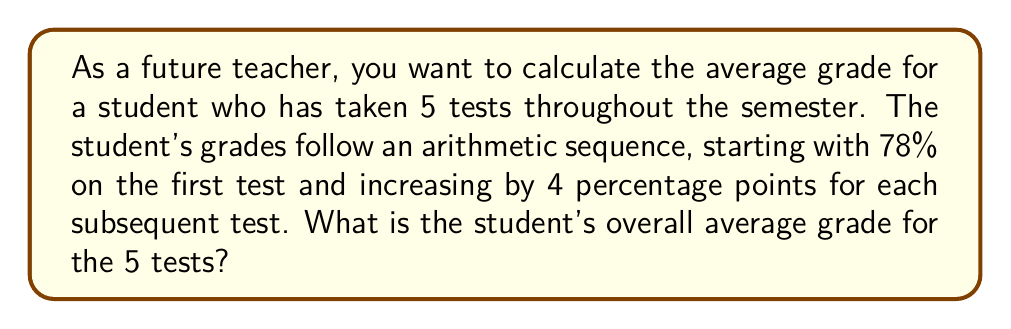Could you help me with this problem? Let's approach this step-by-step using the concept of arithmetic series:

1) First, let's identify the components of our arithmetic sequence:
   $a_1 = 78$ (first term)
   $d = 4$ (common difference)
   $n = 5$ (number of terms)

2) The arithmetic sequence of grades would be:
   78, 82, 86, 90, 94

3) To find the average, we need to find the sum of all grades and divide by the number of tests.

4) We can use the formula for the sum of an arithmetic series:
   $$S_n = \frac{n}{2}(a_1 + a_n)$$
   where $S_n$ is the sum of the series, $n$ is the number of terms, $a_1$ is the first term, and $a_n$ is the last term.

5) We know $a_1 = 78$ and $n = 5$, but we need to calculate $a_n$:
   $a_n = a_1 + (n-1)d = 78 + (5-1)4 = 78 + 16 = 94$

6) Now we can plug these values into our formula:
   $$S_5 = \frac{5}{2}(78 + 94) = \frac{5}{2}(172) = 430$$

7) To get the average, we divide the sum by the number of tests:
   $$\text{Average} = \frac{430}{5} = 86$$

Therefore, the student's overall average grade is 86%.
Answer: The student's overall average grade for the 5 tests is 86%. 